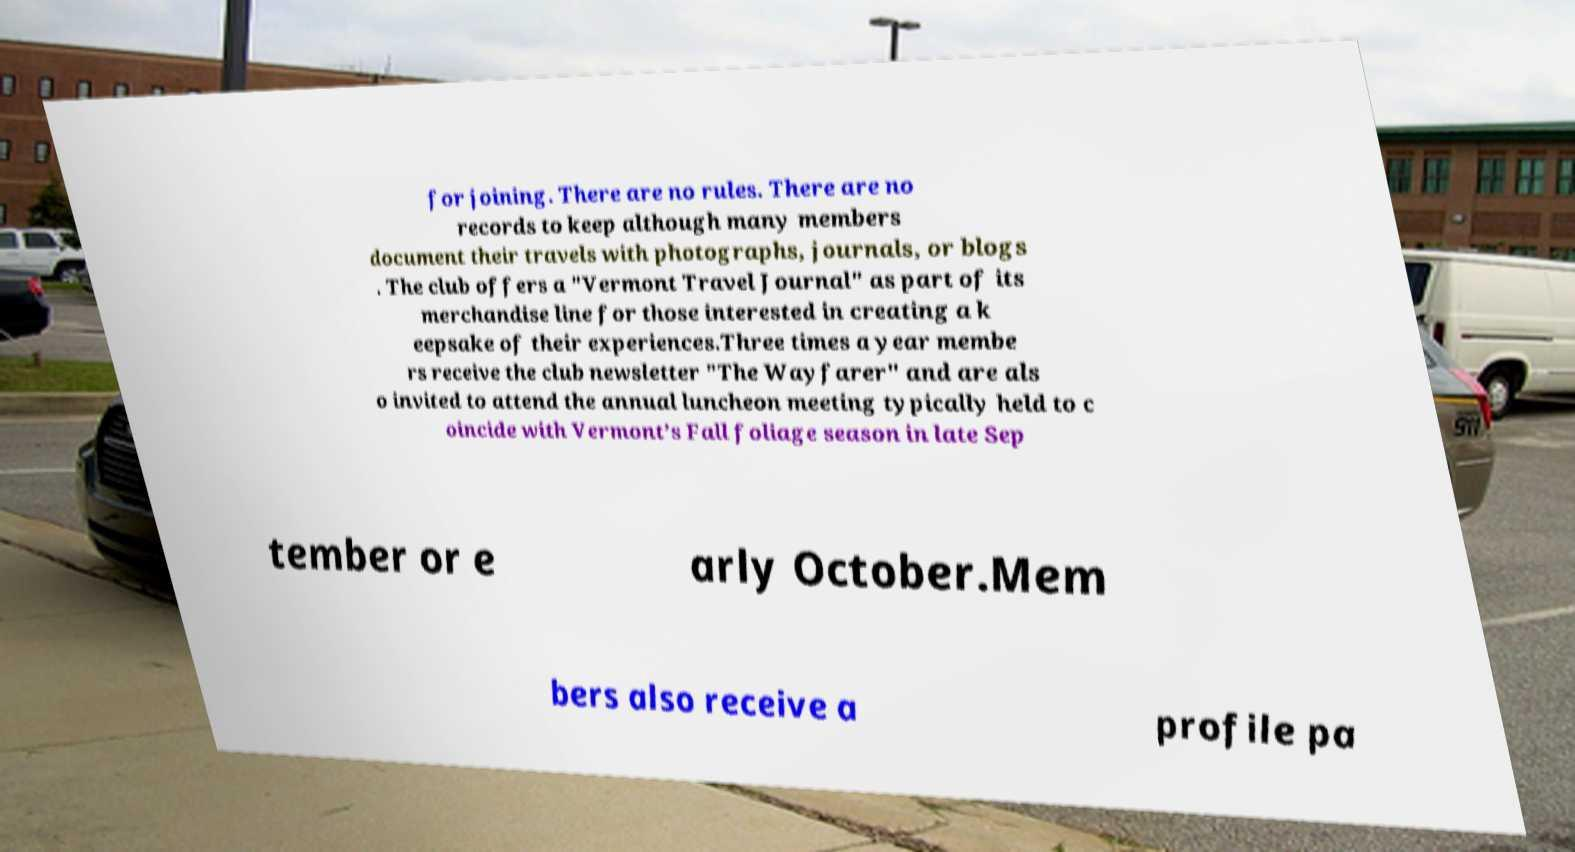Can you accurately transcribe the text from the provided image for me? for joining. There are no rules. There are no records to keep although many members document their travels with photographs, journals, or blogs . The club offers a "Vermont Travel Journal" as part of its merchandise line for those interested in creating a k eepsake of their experiences.Three times a year membe rs receive the club newsletter "The Wayfarer" and are als o invited to attend the annual luncheon meeting typically held to c oincide with Vermont’s Fall foliage season in late Sep tember or e arly October.Mem bers also receive a profile pa 